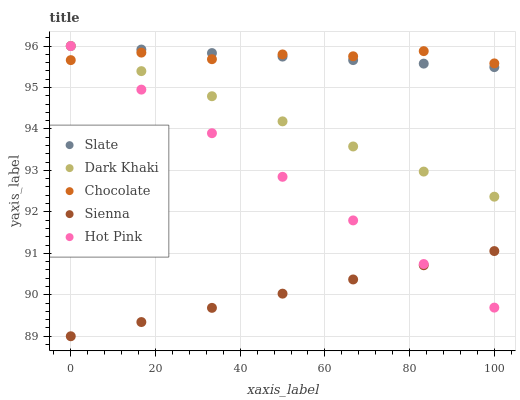Does Sienna have the minimum area under the curve?
Answer yes or no. Yes. Does Chocolate have the maximum area under the curve?
Answer yes or no. Yes. Does Slate have the minimum area under the curve?
Answer yes or no. No. Does Slate have the maximum area under the curve?
Answer yes or no. No. Is Slate the smoothest?
Answer yes or no. Yes. Is Chocolate the roughest?
Answer yes or no. Yes. Is Sienna the smoothest?
Answer yes or no. No. Is Sienna the roughest?
Answer yes or no. No. Does Sienna have the lowest value?
Answer yes or no. Yes. Does Slate have the lowest value?
Answer yes or no. No. Does Hot Pink have the highest value?
Answer yes or no. Yes. Does Sienna have the highest value?
Answer yes or no. No. Is Sienna less than Dark Khaki?
Answer yes or no. Yes. Is Dark Khaki greater than Sienna?
Answer yes or no. Yes. Does Chocolate intersect Hot Pink?
Answer yes or no. Yes. Is Chocolate less than Hot Pink?
Answer yes or no. No. Is Chocolate greater than Hot Pink?
Answer yes or no. No. Does Sienna intersect Dark Khaki?
Answer yes or no. No. 